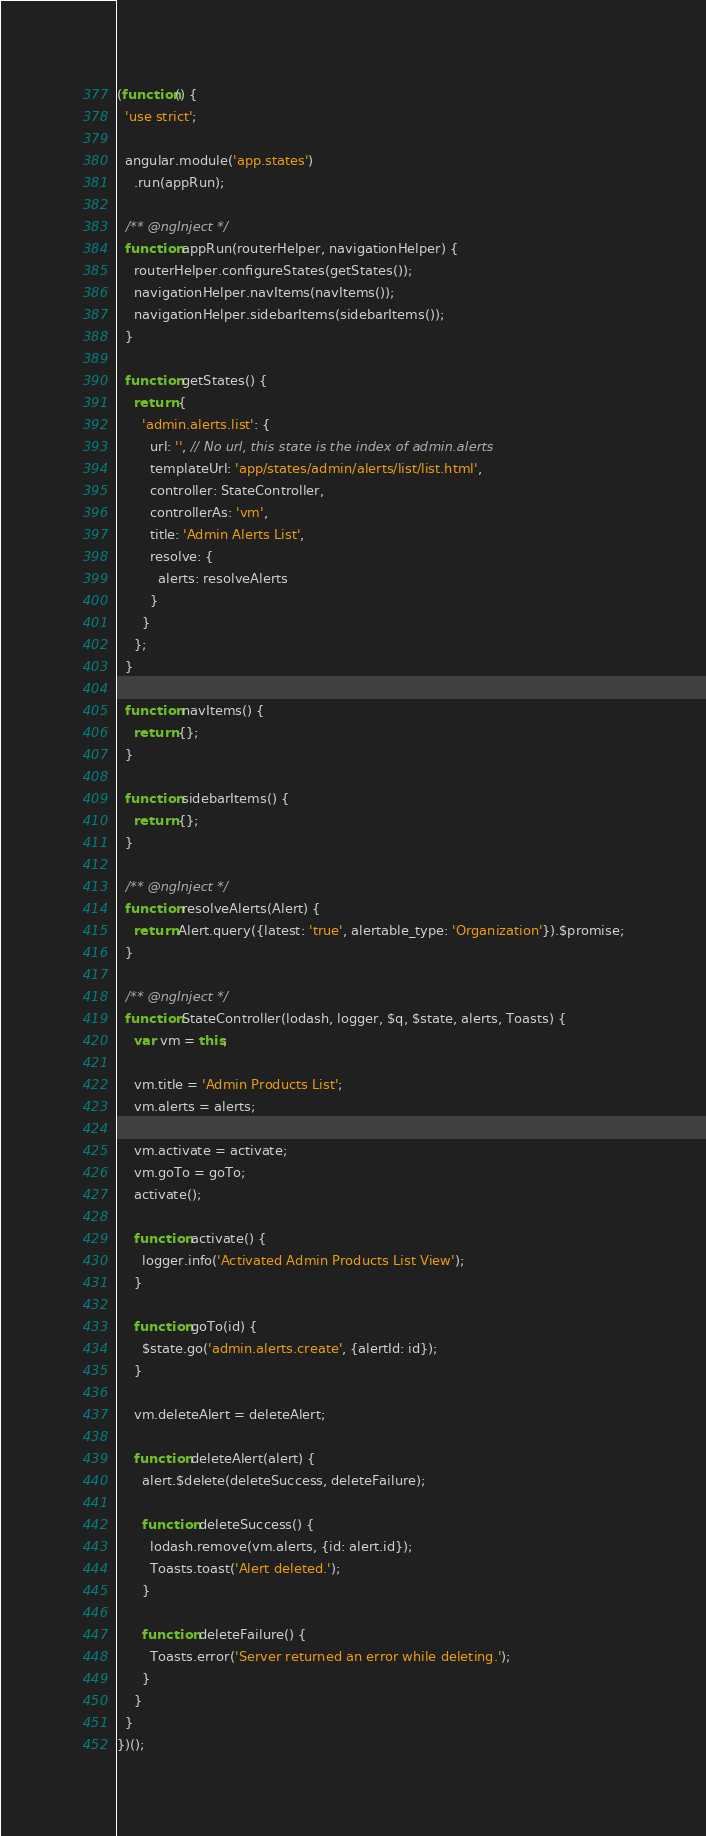<code> <loc_0><loc_0><loc_500><loc_500><_JavaScript_>(function() {
  'use strict';

  angular.module('app.states')
    .run(appRun);

  /** @ngInject */
  function appRun(routerHelper, navigationHelper) {
    routerHelper.configureStates(getStates());
    navigationHelper.navItems(navItems());
    navigationHelper.sidebarItems(sidebarItems());
  }

  function getStates() {
    return {
      'admin.alerts.list': {
        url: '', // No url, this state is the index of admin.alerts
        templateUrl: 'app/states/admin/alerts/list/list.html',
        controller: StateController,
        controllerAs: 'vm',
        title: 'Admin Alerts List',
        resolve: {
          alerts: resolveAlerts
        }
      }
    };
  }

  function navItems() {
    return {};
  }

  function sidebarItems() {
    return {};
  }

  /** @ngInject */
  function resolveAlerts(Alert) {
    return Alert.query({latest: 'true', alertable_type: 'Organization'}).$promise;
  }

  /** @ngInject */
  function StateController(lodash, logger, $q, $state, alerts, Toasts) {
    var vm = this;

    vm.title = 'Admin Products List';
    vm.alerts = alerts;

    vm.activate = activate;
    vm.goTo = goTo;
    activate();

    function activate() {
      logger.info('Activated Admin Products List View');
    }

    function goTo(id) {
      $state.go('admin.alerts.create', {alertId: id});
    }

    vm.deleteAlert = deleteAlert;

    function deleteAlert(alert) {
      alert.$delete(deleteSuccess, deleteFailure);

      function deleteSuccess() {
        lodash.remove(vm.alerts, {id: alert.id});
        Toasts.toast('Alert deleted.');
      }

      function deleteFailure() {
        Toasts.error('Server returned an error while deleting.');
      }
    }
  }
})();
</code> 